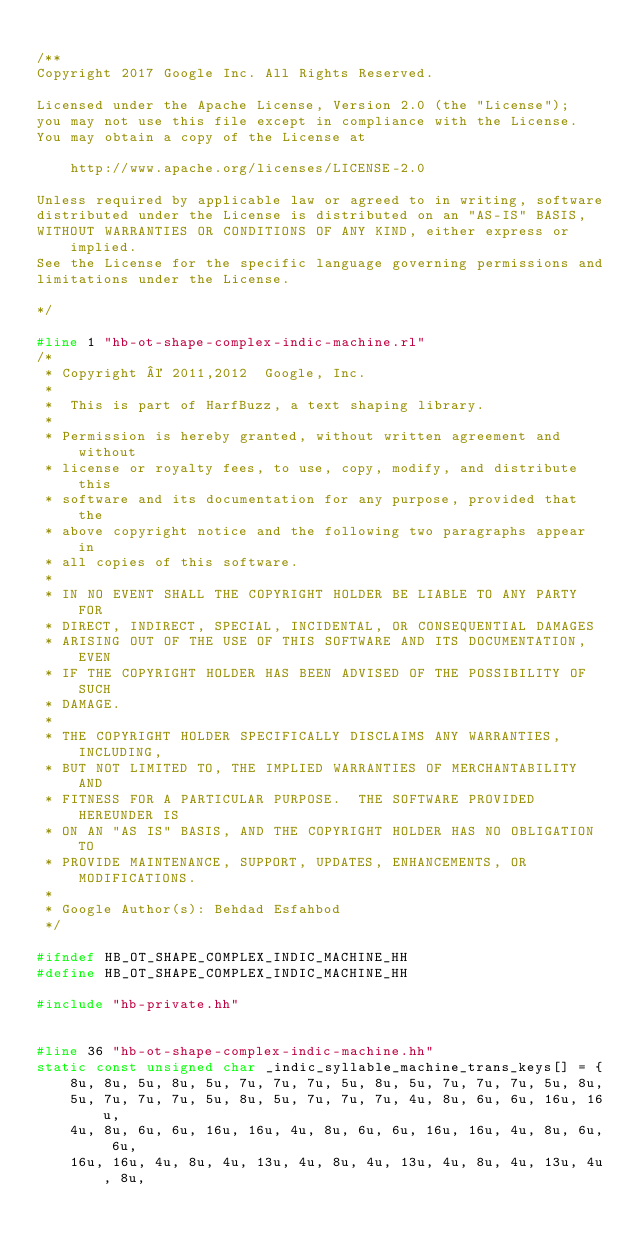<code> <loc_0><loc_0><loc_500><loc_500><_C++_>
/**
Copyright 2017 Google Inc. All Rights Reserved.

Licensed under the Apache License, Version 2.0 (the "License");
you may not use this file except in compliance with the License.
You may obtain a copy of the License at

    http://www.apache.org/licenses/LICENSE-2.0

Unless required by applicable law or agreed to in writing, software
distributed under the License is distributed on an "AS-IS" BASIS,
WITHOUT WARRANTIES OR CONDITIONS OF ANY KIND, either express or implied.
See the License for the specific language governing permissions and
limitations under the License.

*/

#line 1 "hb-ot-shape-complex-indic-machine.rl"
/*
 * Copyright © 2011,2012  Google, Inc.
 *
 *  This is part of HarfBuzz, a text shaping library.
 *
 * Permission is hereby granted, without written agreement and without
 * license or royalty fees, to use, copy, modify, and distribute this
 * software and its documentation for any purpose, provided that the
 * above copyright notice and the following two paragraphs appear in
 * all copies of this software.
 *
 * IN NO EVENT SHALL THE COPYRIGHT HOLDER BE LIABLE TO ANY PARTY FOR
 * DIRECT, INDIRECT, SPECIAL, INCIDENTAL, OR CONSEQUENTIAL DAMAGES
 * ARISING OUT OF THE USE OF THIS SOFTWARE AND ITS DOCUMENTATION, EVEN
 * IF THE COPYRIGHT HOLDER HAS BEEN ADVISED OF THE POSSIBILITY OF SUCH
 * DAMAGE.
 *
 * THE COPYRIGHT HOLDER SPECIFICALLY DISCLAIMS ANY WARRANTIES, INCLUDING,
 * BUT NOT LIMITED TO, THE IMPLIED WARRANTIES OF MERCHANTABILITY AND
 * FITNESS FOR A PARTICULAR PURPOSE.  THE SOFTWARE PROVIDED HEREUNDER IS
 * ON AN "AS IS" BASIS, AND THE COPYRIGHT HOLDER HAS NO OBLIGATION TO
 * PROVIDE MAINTENANCE, SUPPORT, UPDATES, ENHANCEMENTS, OR MODIFICATIONS.
 *
 * Google Author(s): Behdad Esfahbod
 */

#ifndef HB_OT_SHAPE_COMPLEX_INDIC_MACHINE_HH
#define HB_OT_SHAPE_COMPLEX_INDIC_MACHINE_HH

#include "hb-private.hh"


#line 36 "hb-ot-shape-complex-indic-machine.hh"
static const unsigned char _indic_syllable_machine_trans_keys[] = {
	8u, 8u, 5u, 8u, 5u, 7u, 7u, 7u, 5u, 8u, 5u, 7u, 7u, 7u, 5u, 8u, 
	5u, 7u, 7u, 7u, 5u, 8u, 5u, 7u, 7u, 7u, 4u, 8u, 6u, 6u, 16u, 16u, 
	4u, 8u, 6u, 6u, 16u, 16u, 4u, 8u, 6u, 6u, 16u, 16u, 4u, 8u, 6u, 6u, 
	16u, 16u, 4u, 8u, 4u, 13u, 4u, 8u, 4u, 13u, 4u, 8u, 4u, 13u, 4u, 8u, </code> 